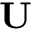Convert formula to latex. <formula><loc_0><loc_0><loc_500><loc_500>U</formula> 